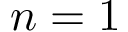Convert formula to latex. <formula><loc_0><loc_0><loc_500><loc_500>n = 1</formula> 